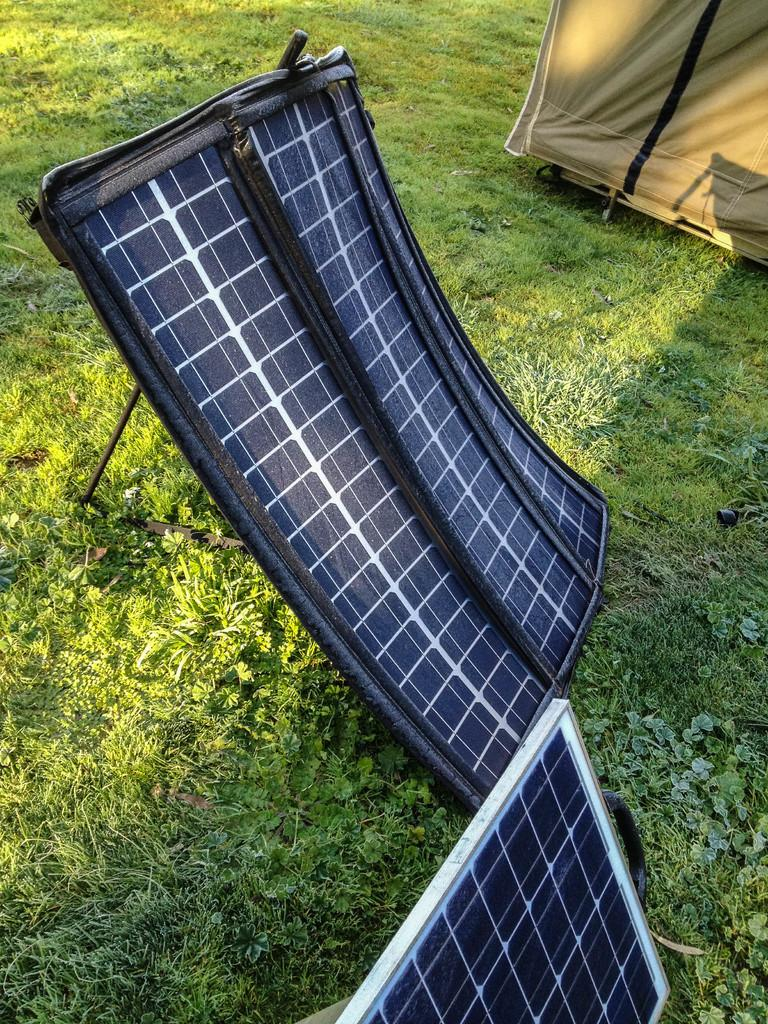What type of vegetation is present at the bottom of the image? There is grass and small plants at the bottom of the image. What can be seen in the foreground of the image? There are solar panels in the foreground of the image. What structure is visible in the right corner of the image? There appears to be a tent in the right corner of the image. How many nerves can be seen in the image? There are no nerves visible in the image. What type of jelly is present in the image? There is no jelly present in the image. 